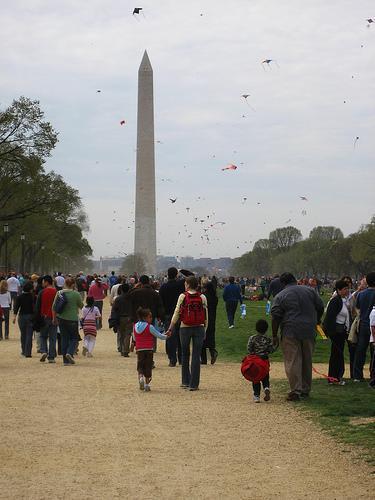How many monuments are pictured?
Give a very brief answer. 1. 